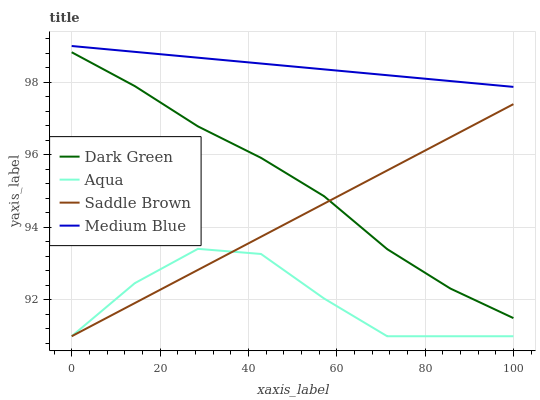Does Aqua have the minimum area under the curve?
Answer yes or no. Yes. Does Medium Blue have the maximum area under the curve?
Answer yes or no. Yes. Does Saddle Brown have the minimum area under the curve?
Answer yes or no. No. Does Saddle Brown have the maximum area under the curve?
Answer yes or no. No. Is Saddle Brown the smoothest?
Answer yes or no. Yes. Is Aqua the roughest?
Answer yes or no. Yes. Is Aqua the smoothest?
Answer yes or no. No. Is Saddle Brown the roughest?
Answer yes or no. No. Does Aqua have the lowest value?
Answer yes or no. Yes. Does Dark Green have the lowest value?
Answer yes or no. No. Does Medium Blue have the highest value?
Answer yes or no. Yes. Does Saddle Brown have the highest value?
Answer yes or no. No. Is Dark Green less than Medium Blue?
Answer yes or no. Yes. Is Medium Blue greater than Saddle Brown?
Answer yes or no. Yes. Does Aqua intersect Saddle Brown?
Answer yes or no. Yes. Is Aqua less than Saddle Brown?
Answer yes or no. No. Is Aqua greater than Saddle Brown?
Answer yes or no. No. Does Dark Green intersect Medium Blue?
Answer yes or no. No. 